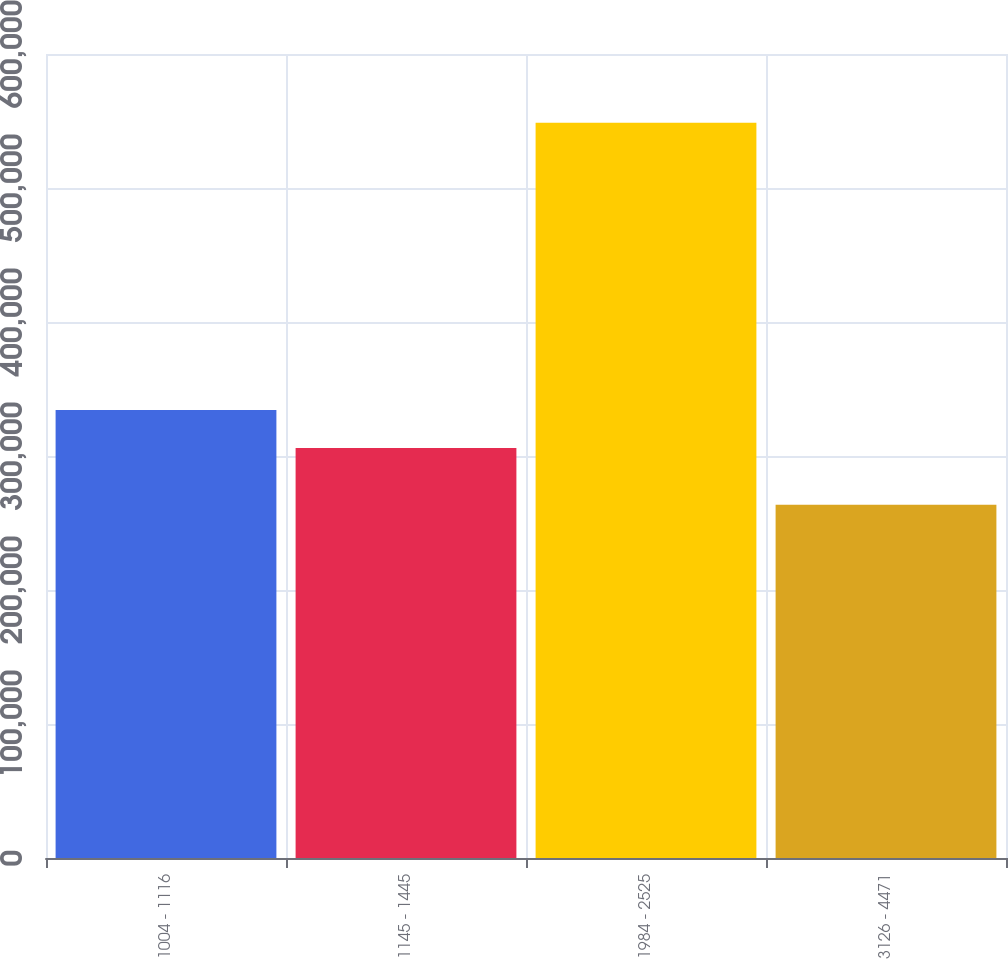Convert chart to OTSL. <chart><loc_0><loc_0><loc_500><loc_500><bar_chart><fcel>1004 - 1116<fcel>1145 - 1445<fcel>1984 - 2525<fcel>3126 - 4471<nl><fcel>334392<fcel>305888<fcel>548645<fcel>263602<nl></chart> 